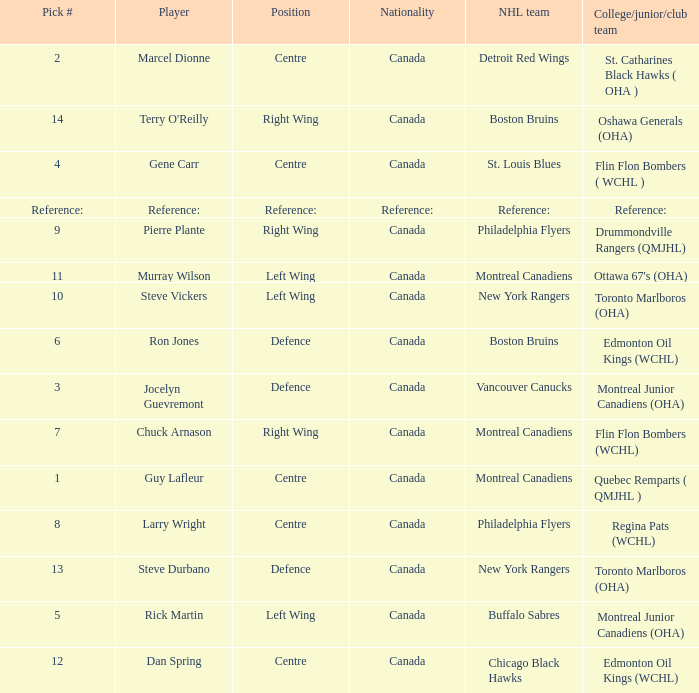Which Pick # has an NHL team of detroit red wings? 2.0. 